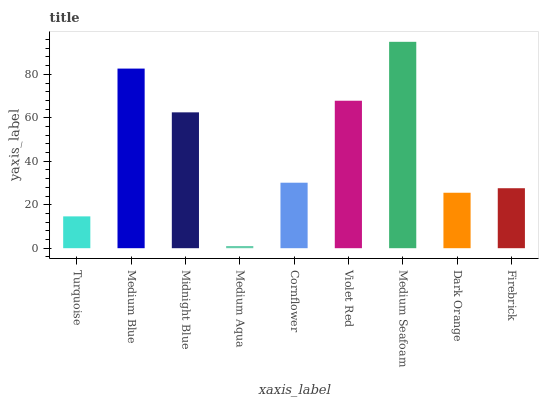Is Medium Aqua the minimum?
Answer yes or no. Yes. Is Medium Seafoam the maximum?
Answer yes or no. Yes. Is Medium Blue the minimum?
Answer yes or no. No. Is Medium Blue the maximum?
Answer yes or no. No. Is Medium Blue greater than Turquoise?
Answer yes or no. Yes. Is Turquoise less than Medium Blue?
Answer yes or no. Yes. Is Turquoise greater than Medium Blue?
Answer yes or no. No. Is Medium Blue less than Turquoise?
Answer yes or no. No. Is Cornflower the high median?
Answer yes or no. Yes. Is Cornflower the low median?
Answer yes or no. Yes. Is Midnight Blue the high median?
Answer yes or no. No. Is Midnight Blue the low median?
Answer yes or no. No. 